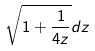Convert formula to latex. <formula><loc_0><loc_0><loc_500><loc_500>\sqrt { 1 + \frac { 1 } { 4 z } } d z</formula> 